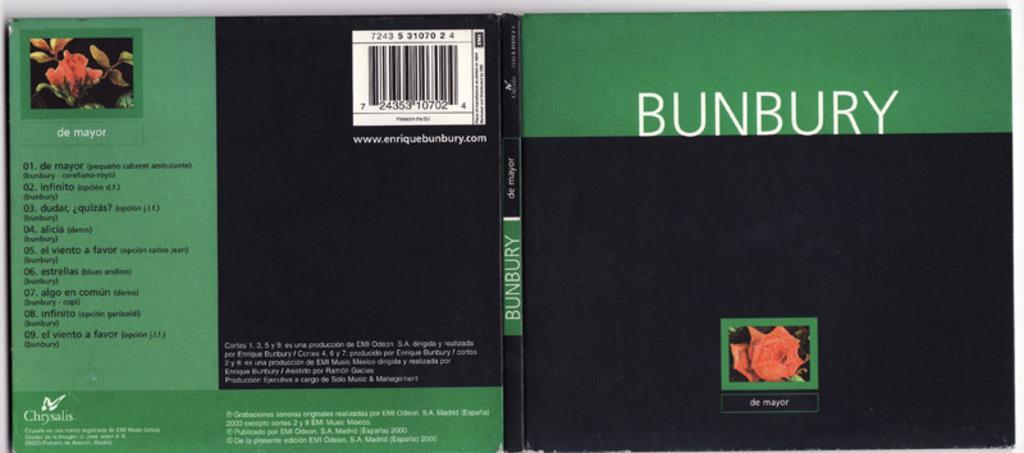Can you describe this image briefly? This image is a cover page of a green and black combination book. In this image there are two flowers visible. There is a black and also white color text on the book. Bar code is also visible. 